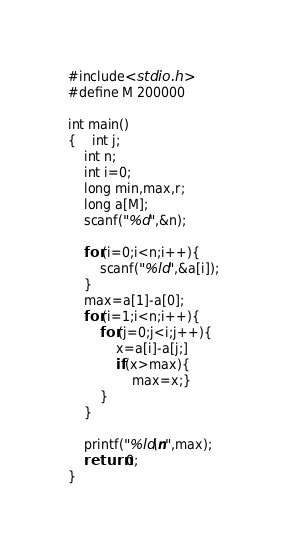<code> <loc_0><loc_0><loc_500><loc_500><_C_>#include<stdio.h>
#define M 200000

int main()
{	int j;
	int n;
	int i=0;
	long min,max,r;
	long a[M];
	scanf("%d",&n);
	
	for(i=0;i<n;i++){
		scanf("%ld",&a[i]);
	}
	max=a[1]-a[0];
	for(i=1;i<n;i++){
		for(j=0;j<i;j++){
			x=a[i]-a[j;]
			if(x>max){
				max=x;}
		}
	}
	
	printf("%ld\n",max);
	return 0;
}</code> 